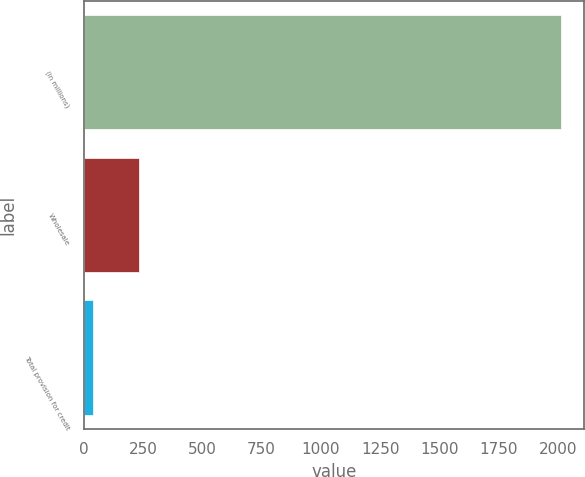<chart> <loc_0><loc_0><loc_500><loc_500><bar_chart><fcel>(in millions)<fcel>Wholesale<fcel>Total provision for credit<nl><fcel>2011<fcel>235.3<fcel>38<nl></chart> 